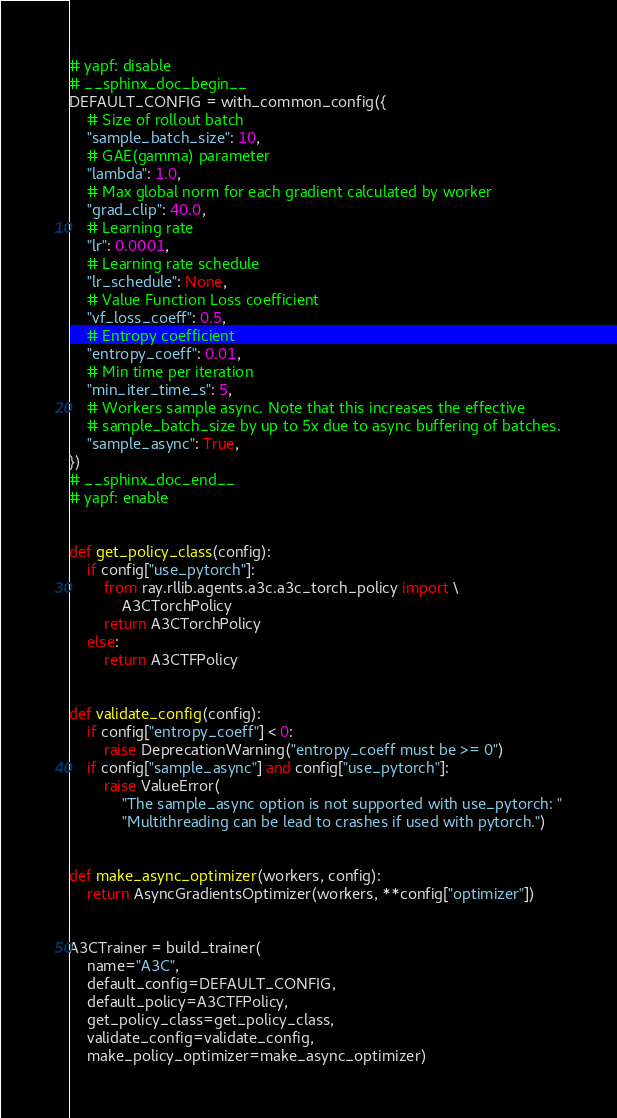<code> <loc_0><loc_0><loc_500><loc_500><_Python_># yapf: disable
# __sphinx_doc_begin__
DEFAULT_CONFIG = with_common_config({
    # Size of rollout batch
    "sample_batch_size": 10,
    # GAE(gamma) parameter
    "lambda": 1.0,
    # Max global norm for each gradient calculated by worker
    "grad_clip": 40.0,
    # Learning rate
    "lr": 0.0001,
    # Learning rate schedule
    "lr_schedule": None,
    # Value Function Loss coefficient
    "vf_loss_coeff": 0.5,
    # Entropy coefficient
    "entropy_coeff": 0.01,
    # Min time per iteration
    "min_iter_time_s": 5,
    # Workers sample async. Note that this increases the effective
    # sample_batch_size by up to 5x due to async buffering of batches.
    "sample_async": True,
})
# __sphinx_doc_end__
# yapf: enable


def get_policy_class(config):
    if config["use_pytorch"]:
        from ray.rllib.agents.a3c.a3c_torch_policy import \
            A3CTorchPolicy
        return A3CTorchPolicy
    else:
        return A3CTFPolicy


def validate_config(config):
    if config["entropy_coeff"] < 0:
        raise DeprecationWarning("entropy_coeff must be >= 0")
    if config["sample_async"] and config["use_pytorch"]:
        raise ValueError(
            "The sample_async option is not supported with use_pytorch: "
            "Multithreading can be lead to crashes if used with pytorch.")


def make_async_optimizer(workers, config):
    return AsyncGradientsOptimizer(workers, **config["optimizer"])


A3CTrainer = build_trainer(
    name="A3C",
    default_config=DEFAULT_CONFIG,
    default_policy=A3CTFPolicy,
    get_policy_class=get_policy_class,
    validate_config=validate_config,
    make_policy_optimizer=make_async_optimizer)
</code> 